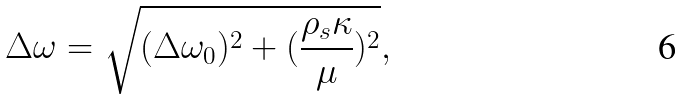Convert formula to latex. <formula><loc_0><loc_0><loc_500><loc_500>\Delta \omega = \sqrt { ( \Delta \omega _ { 0 } ) ^ { 2 } + ( \frac { \rho _ { s } \kappa } { \mu } ) ^ { 2 } } ,</formula> 